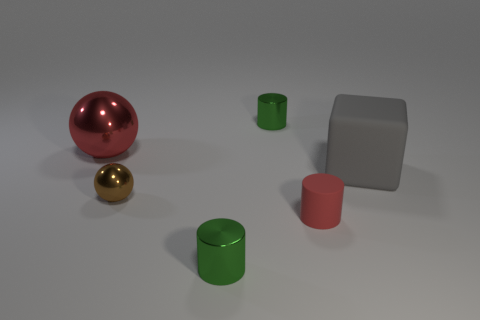What time of day do you think it is based on the lighting in the image? The lighting in the image does not suggest a particular time of day because it appears to be a controlled studio light condition, exhibiting a soft, diffused light with subtle shadows. 